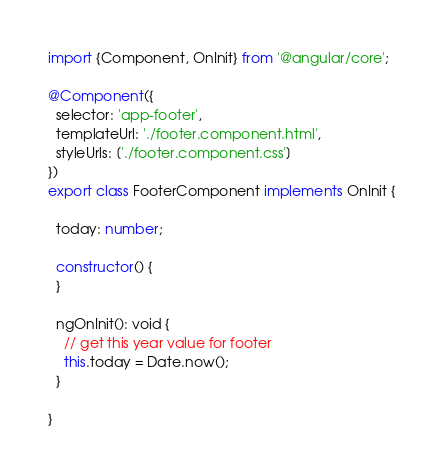<code> <loc_0><loc_0><loc_500><loc_500><_TypeScript_>import {Component, OnInit} from '@angular/core';

@Component({
  selector: 'app-footer',
  templateUrl: './footer.component.html',
  styleUrls: ['./footer.component.css']
})
export class FooterComponent implements OnInit {

  today: number;

  constructor() {
  }

  ngOnInit(): void {
    // get this year value for footer
    this.today = Date.now();
  }

}
</code> 